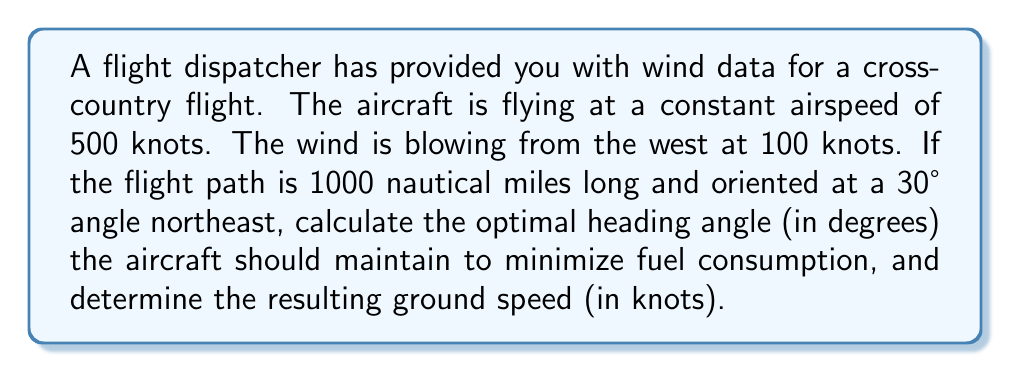Can you solve this math problem? To solve this problem, we need to use vector algebra and trigonometry. Let's break it down step by step:

1) First, we need to understand the wind triangle:
   - True Course (TC): The desired path over the ground (30° NE)
   - True Heading (TH): The direction the aircraft needs to point
   - Wind Correction Angle (WCA): The angle between TC and TH

2) We can represent the velocities as vectors:
   - Aircraft velocity (TAS): 500 knots along TH
   - Wind velocity (W): 100 knots from 270° (west)
   - Ground speed (GS): The resultant vector

3) We need to find the wind correction angle (WCA) and the ground speed (GS).

4) Using the wind triangle, we can set up the following equation:

   $$\vec{GS} = \vec{TAS} + \vec{W}$$

5) Breaking this into components:
   
   $$GS \cos(30°) = TAS \cos(30° + WCA) + 100$$
   $$GS \sin(30°) = TAS \sin(30° + WCA)$$

6) Dividing the second equation by the first:

   $$\tan(30°) = \frac{TAS \sin(30° + WCA)}{TAS \cos(30° + WCA) + 100}$$

7) Simplifying and solving for WCA:

   $$\frac{\sqrt{3}}{3} = \frac{\sin(30° + WCA)}{\cos(30° + WCA) + 0.2}$$

8) This equation can be solved numerically to find WCA ≈ 5.74°

9) The optimal heading angle is therefore:
   
   $$TH = TC + WCA = 30° + 5.74° = 35.74°$$

10) To find the ground speed, we can use the cosine formula:

    $$GS = TAS \cos(WCA) + W \cos(60°)$$
    $$GS = 500 \cos(5.74°) + 100 \cos(60°)$$
    $$GS = 497.5 + 50 = 547.5$$ knots
Answer: The optimal heading angle is approximately 35.74°, and the resulting ground speed is 547.5 knots. 